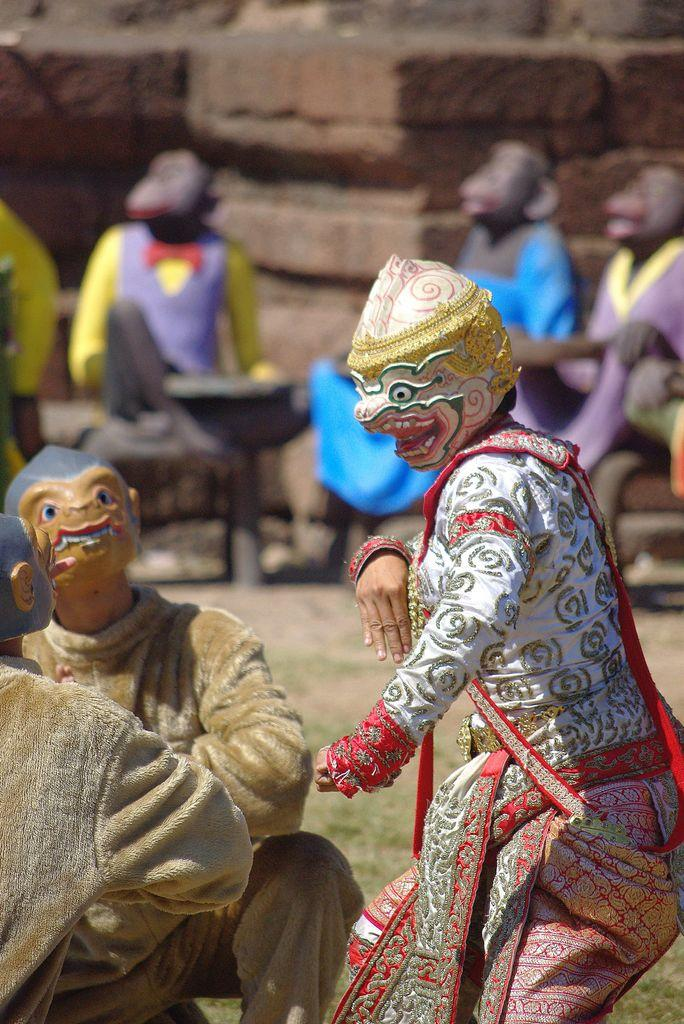How many men are in the foreground of the image? There are three men in the foreground of the image. What are the men wearing in the image? The men are wearing masks and costumes in the image. What can be seen in the background of the image? There are sculptures of monkeys and a wall visible in the background of the image. What type of vegetation is visible in the background of the image? There is grass visible in the background of the image. What type of cake is being served to the horse in the image? There is no cake or horse present in the image. What is the name of the daughter of one of the men in the image? There is no information about the men's daughters in the image. 